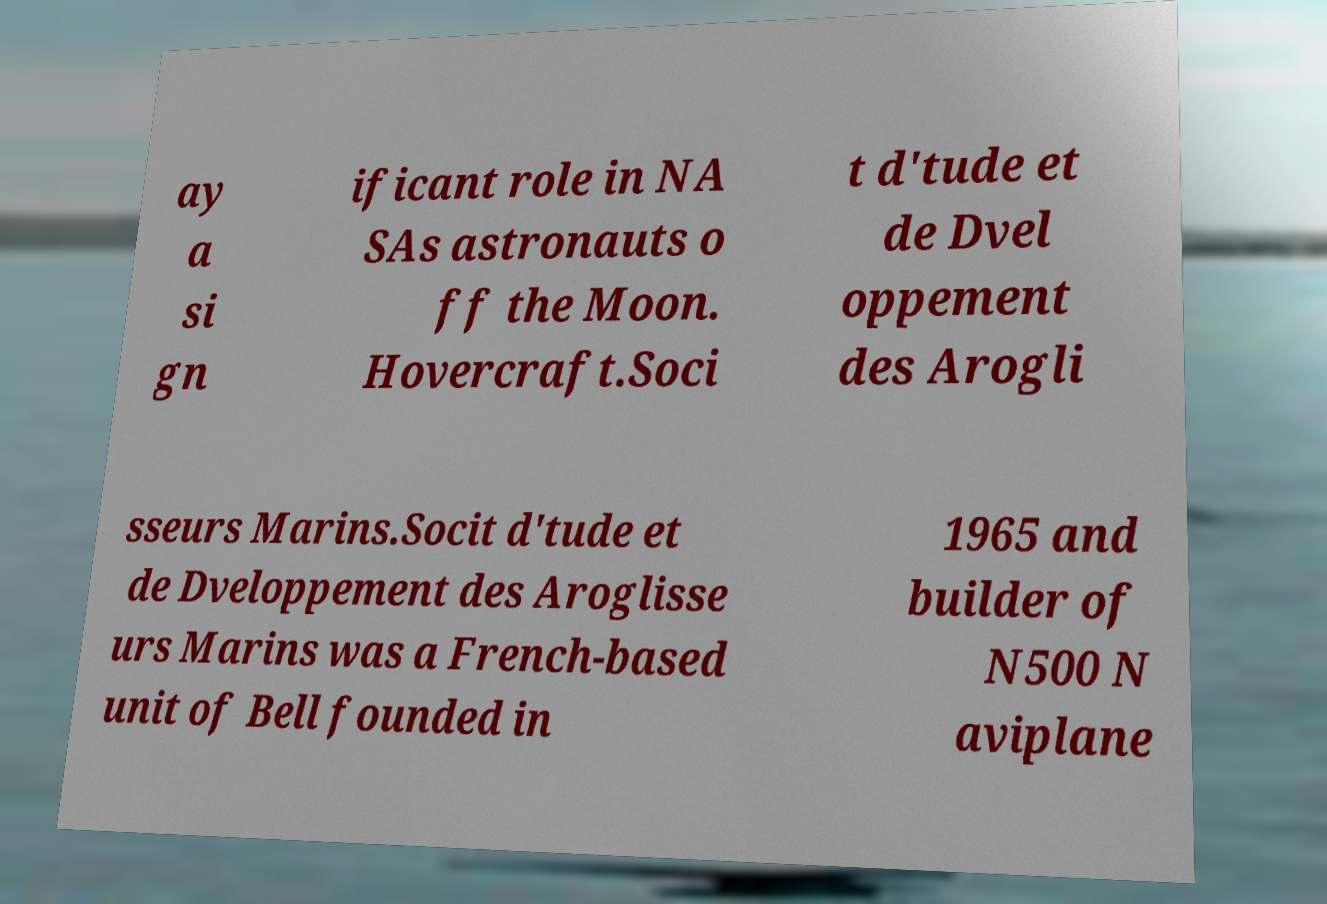Please read and relay the text visible in this image. What does it say? ay a si gn ificant role in NA SAs astronauts o ff the Moon. Hovercraft.Soci t d'tude et de Dvel oppement des Arogli sseurs Marins.Socit d'tude et de Dveloppement des Aroglisse urs Marins was a French-based unit of Bell founded in 1965 and builder of N500 N aviplane 